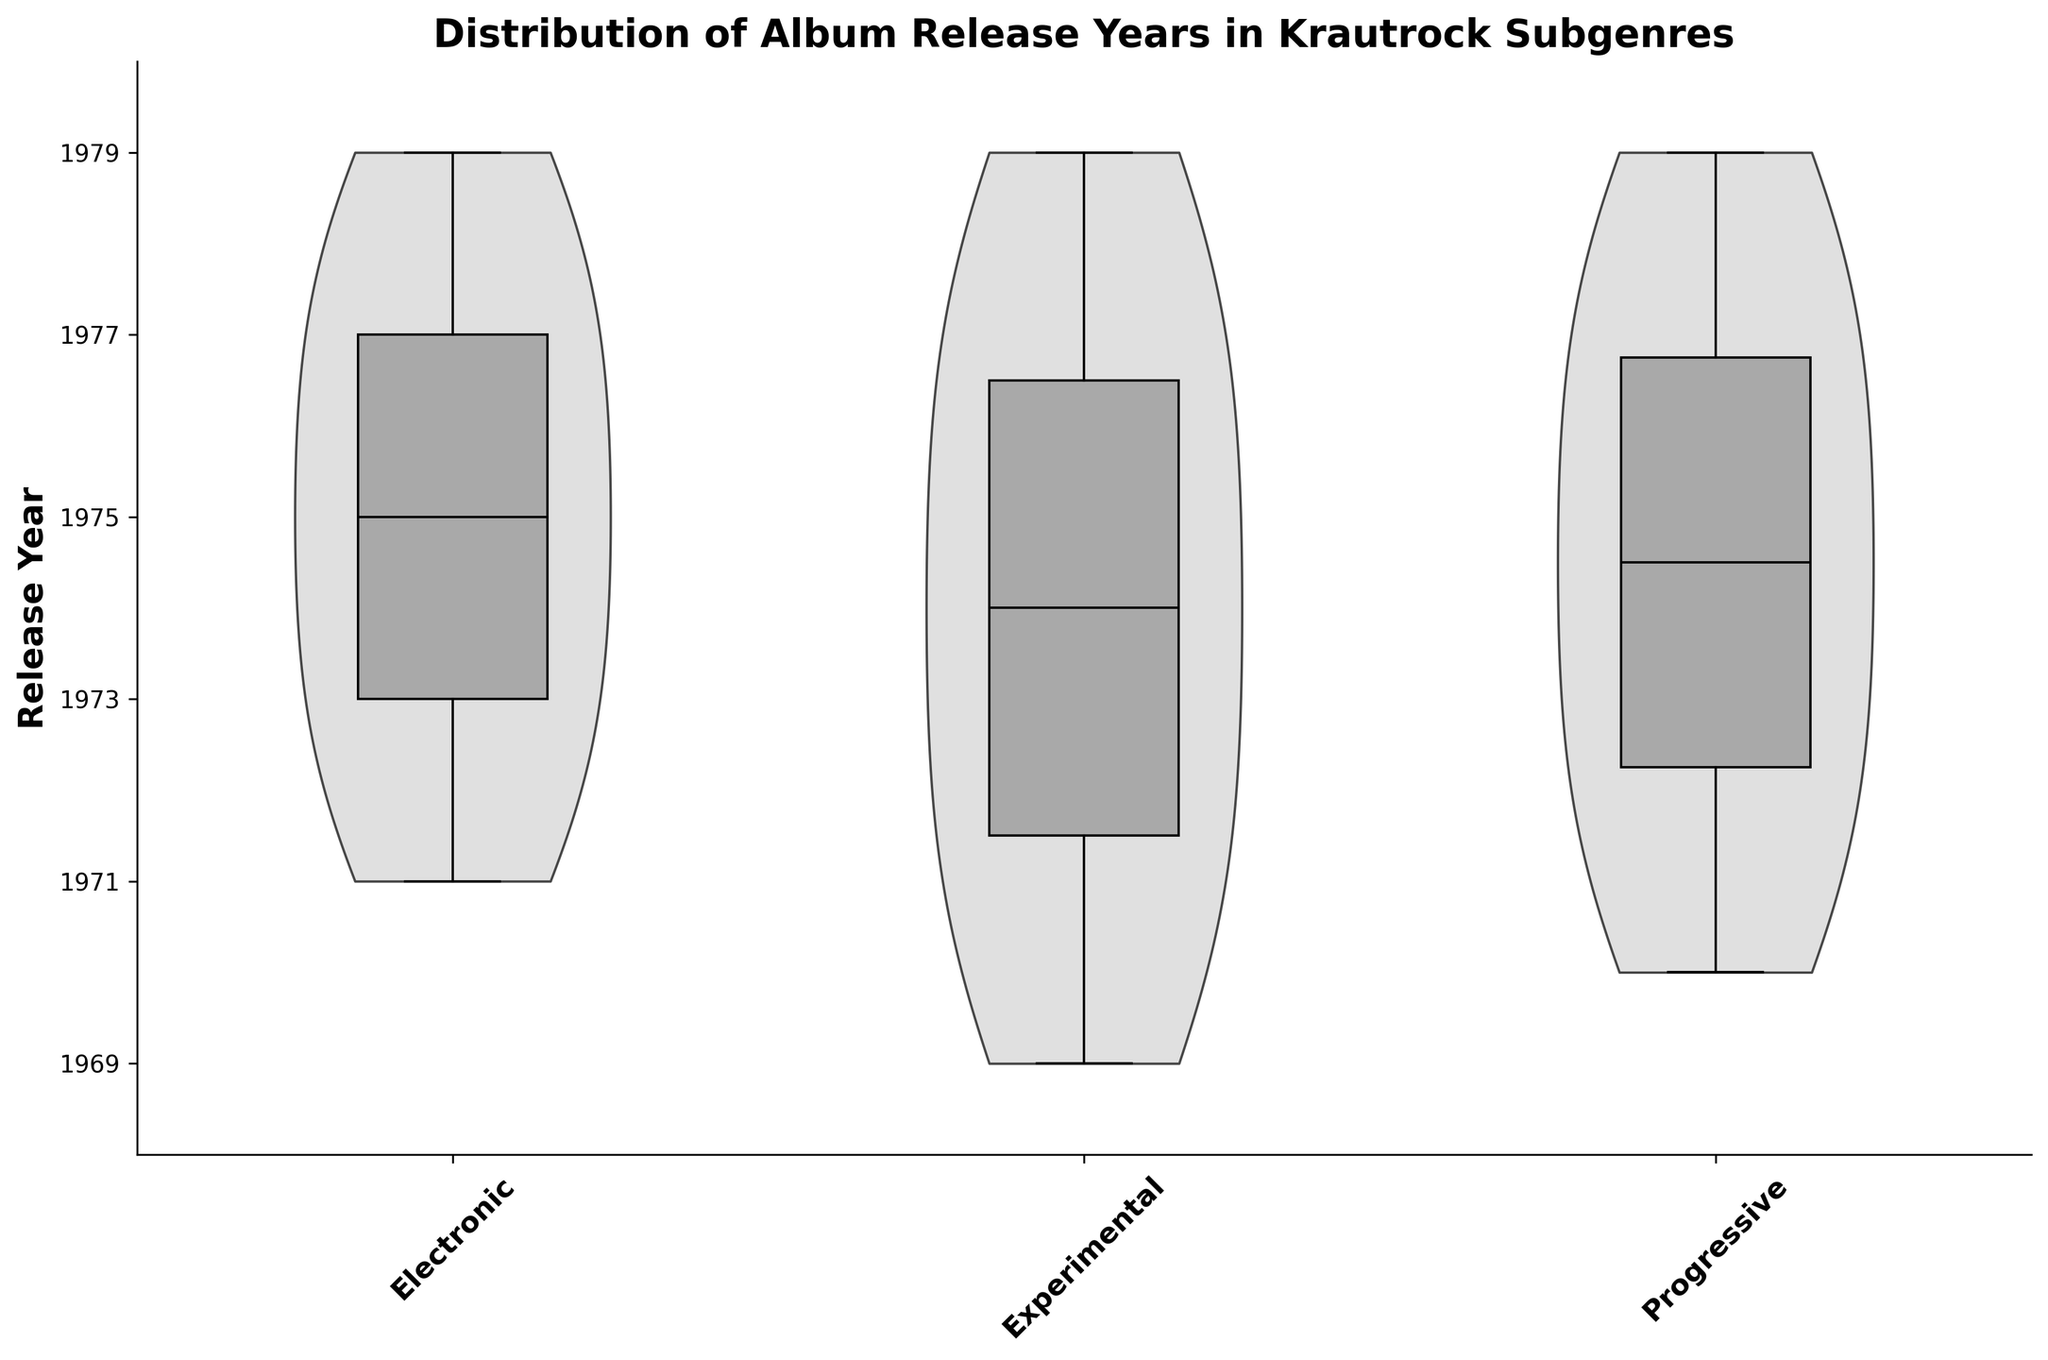what's the title of the figure? The figure's title is shown prominently at the top of the plot.
Answer: Distribution of Album Release Years in Krautrock Subgenres Which subgenre has the highest median release year? By looking at the box plot overlay within each violin plot, you can identify the position of the median marker. The median value for Electronic is higher than Experimental and Progressive.
Answer: Electronic What's the range of release years for the Experimental subgenre? By examining the whiskers of the box plot for the Experimental subgenre, you can spot the minimum and maximum values. Experimental spans from 1969 to 1979.
Answer: 1969 - 1979 Which subgenre shows the widest distribution of release years? The width of the violin plots indicates the distribution spread. Experimental has the widest distribution, spanning from 1969 to 1979.
Answer: Experimental Are there any subgenres where the release years are highly concentrated within a shorter range? By examining the width of the violin plots and the interquartile range (IQR) of the box plots, Experimental shows a wider range, while Progressive appears more concentrated towards the middle values. However, Electronic shows broader variance in the 1970s.
Answer: No Which subgenre has the smallest interquartile range? The interquartile range (IQR) is the width of the box in the box plot. Experimental has the smallest IQR, indicating a more concentrated distribution around the median.
Answer: Experimental During which years is the concentration of Electronic subgenre releases highest, based on the violin plot? The width of the violin plot for the Electronic subgenre is largest around 1974 to 1977.
Answer: 1974-1977 Is the median release year for Progressive earlier than for Experimental? By comparing the median lines in the box plots for the Progressive and Experimental subgenres, the Progressive median line appears at a similar year but does not surpass the Experimental median.
Answer: No Do any subgenres have outliers if they were to be included? Outliers would normally be marked outside the whiskers in a box plot. Since outliers are not shown, it's difficult to determine precisely, but no extreme values in the violin plots indicate potential outliers.
Answer: No Which subgenre shows the most recent release year within the dataset? The most recent year can be identified from the upper whisker in the box plots. Both Electronic and Progressive show releases as recent as 1979.
Answer: Electronic & Progressive 